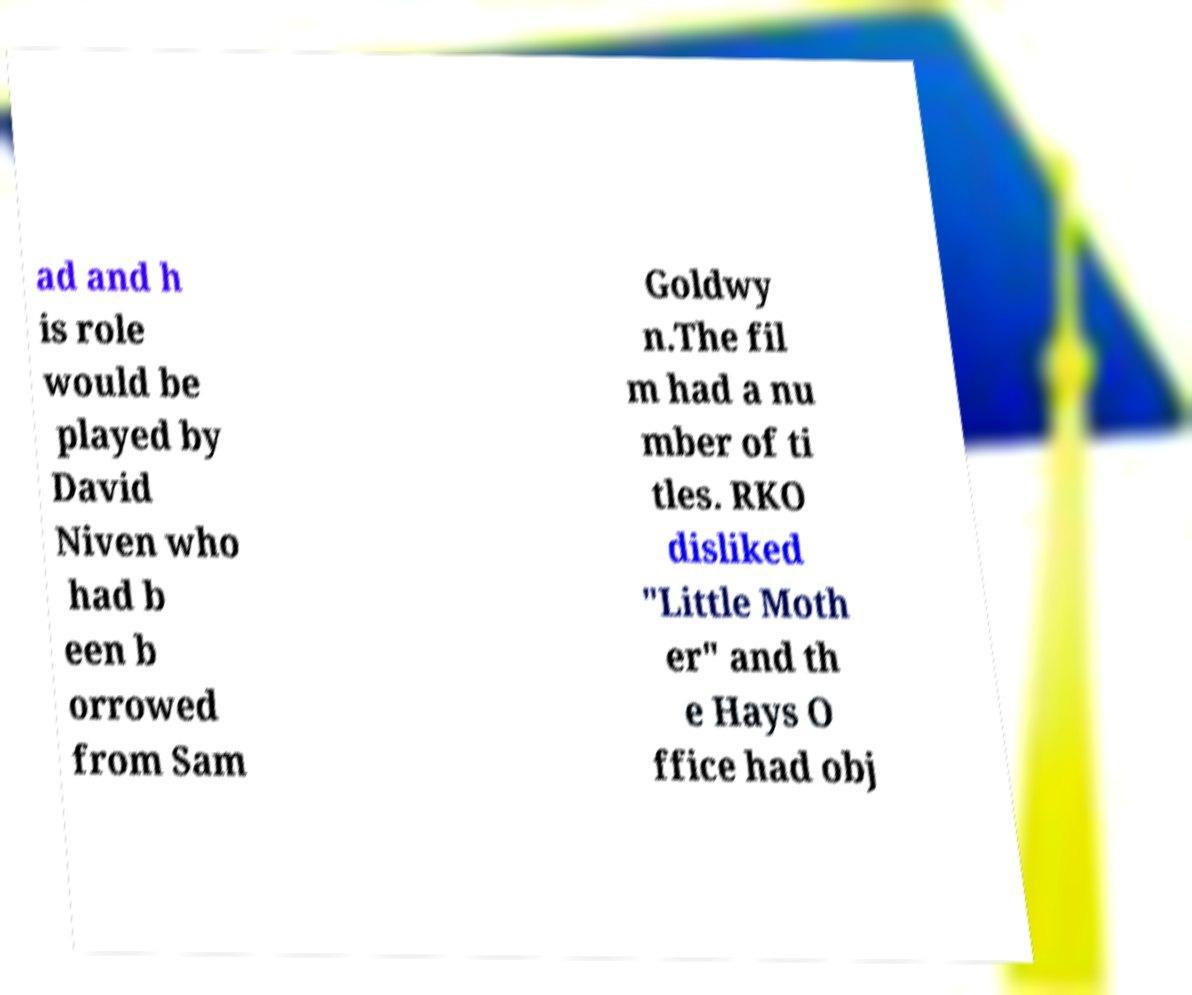Can you accurately transcribe the text from the provided image for me? ad and h is role would be played by David Niven who had b een b orrowed from Sam Goldwy n.The fil m had a nu mber of ti tles. RKO disliked "Little Moth er" and th e Hays O ffice had obj 